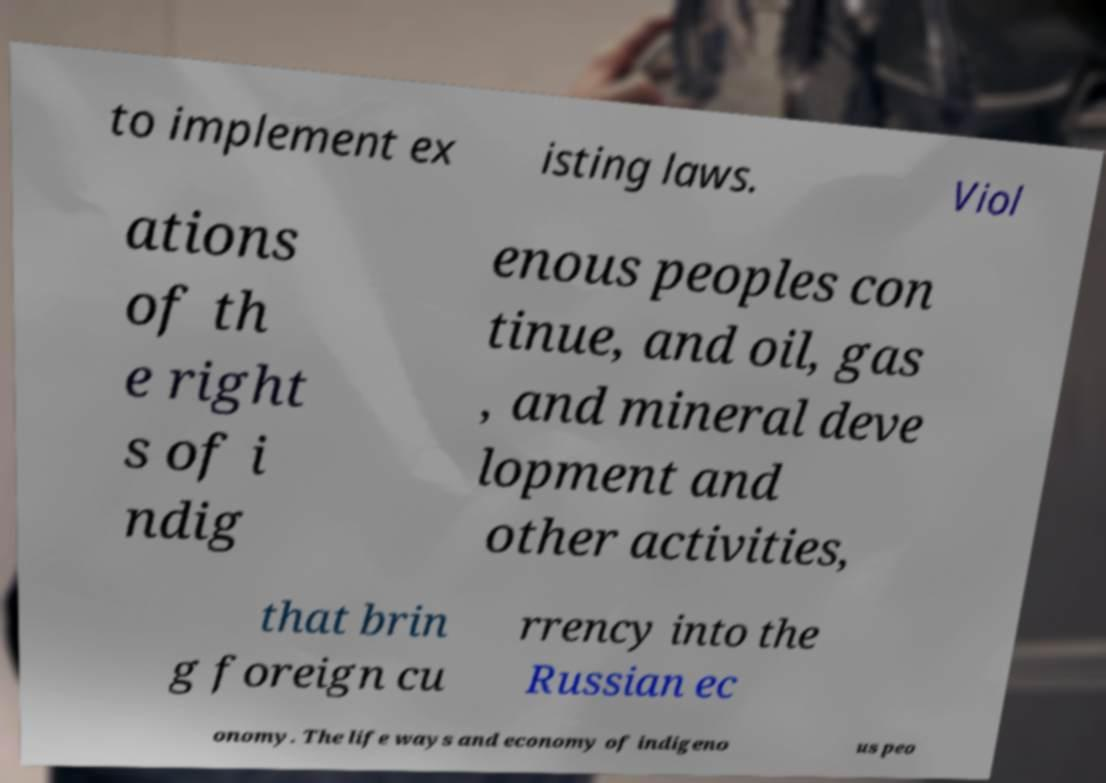Could you assist in decoding the text presented in this image and type it out clearly? to implement ex isting laws. Viol ations of th e right s of i ndig enous peoples con tinue, and oil, gas , and mineral deve lopment and other activities, that brin g foreign cu rrency into the Russian ec onomy. The life ways and economy of indigeno us peo 